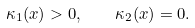Convert formula to latex. <formula><loc_0><loc_0><loc_500><loc_500>\kappa _ { 1 } ( x ) > 0 , \quad \kappa _ { 2 } ( x ) = 0 .</formula> 